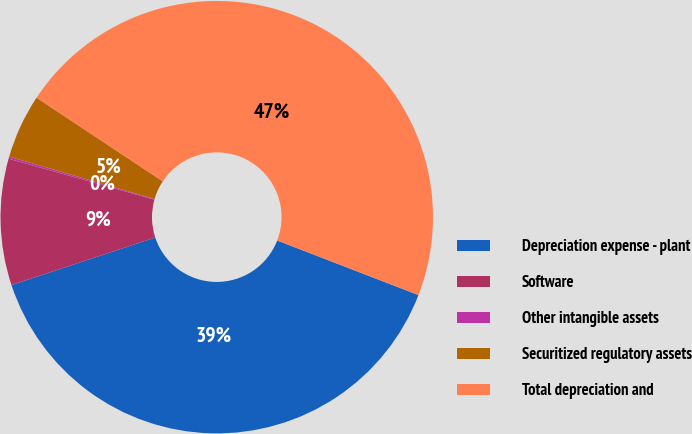Convert chart. <chart><loc_0><loc_0><loc_500><loc_500><pie_chart><fcel>Depreciation expense - plant<fcel>Software<fcel>Other intangible assets<fcel>Securitized regulatory assets<fcel>Total depreciation and<nl><fcel>39.05%<fcel>9.44%<fcel>0.16%<fcel>4.8%<fcel>46.55%<nl></chart> 